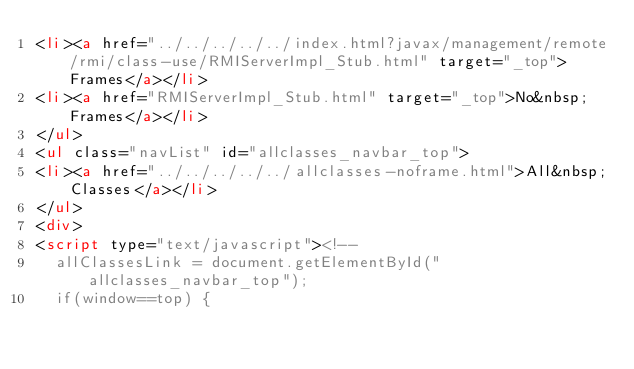<code> <loc_0><loc_0><loc_500><loc_500><_HTML_><li><a href="../../../../../index.html?javax/management/remote/rmi/class-use/RMIServerImpl_Stub.html" target="_top">Frames</a></li>
<li><a href="RMIServerImpl_Stub.html" target="_top">No&nbsp;Frames</a></li>
</ul>
<ul class="navList" id="allclasses_navbar_top">
<li><a href="../../../../../allclasses-noframe.html">All&nbsp;Classes</a></li>
</ul>
<div>
<script type="text/javascript"><!--
  allClassesLink = document.getElementById("allclasses_navbar_top");
  if(window==top) {</code> 